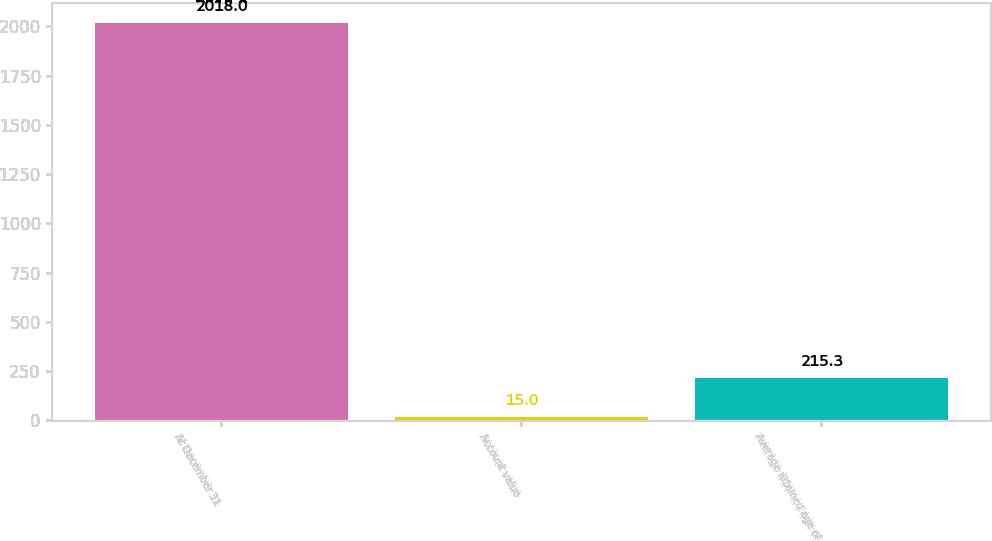Convert chart to OTSL. <chart><loc_0><loc_0><loc_500><loc_500><bar_chart><fcel>At December 31<fcel>Account value<fcel>Average attained age of<nl><fcel>2018<fcel>15<fcel>215.3<nl></chart> 